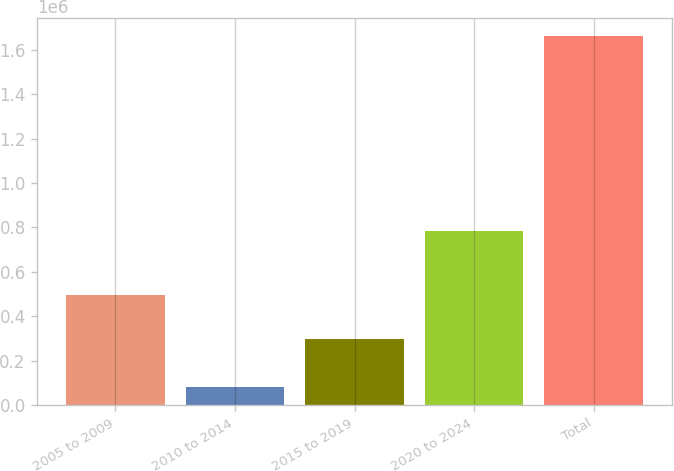Convert chart. <chart><loc_0><loc_0><loc_500><loc_500><bar_chart><fcel>2005 to 2009<fcel>2010 to 2014<fcel>2015 to 2019<fcel>2020 to 2024<fcel>Total<nl><fcel>497122<fcel>81245<fcel>299780<fcel>782318<fcel>1.66046e+06<nl></chart> 